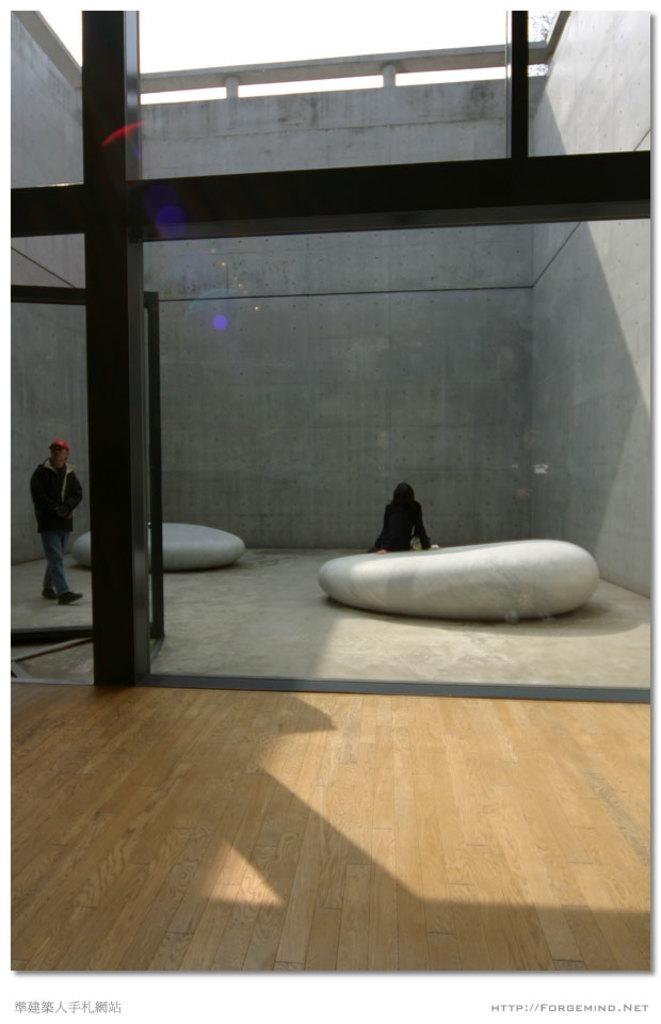How many people are in the image? There are two persons in the image. What is the setting of the image? The persons are between walls. What architectural feature can be seen on the left side of the image? There is a pillar on the left side of the image. What is visible at the top of the image? The sky is visible at the top of the image. What type of cord is being used by the persons in the image? There is no cord visible in the image. What is the common interest of the persons in the image? The image does not provide information about the persons' interests, so it cannot be determined from the image. 